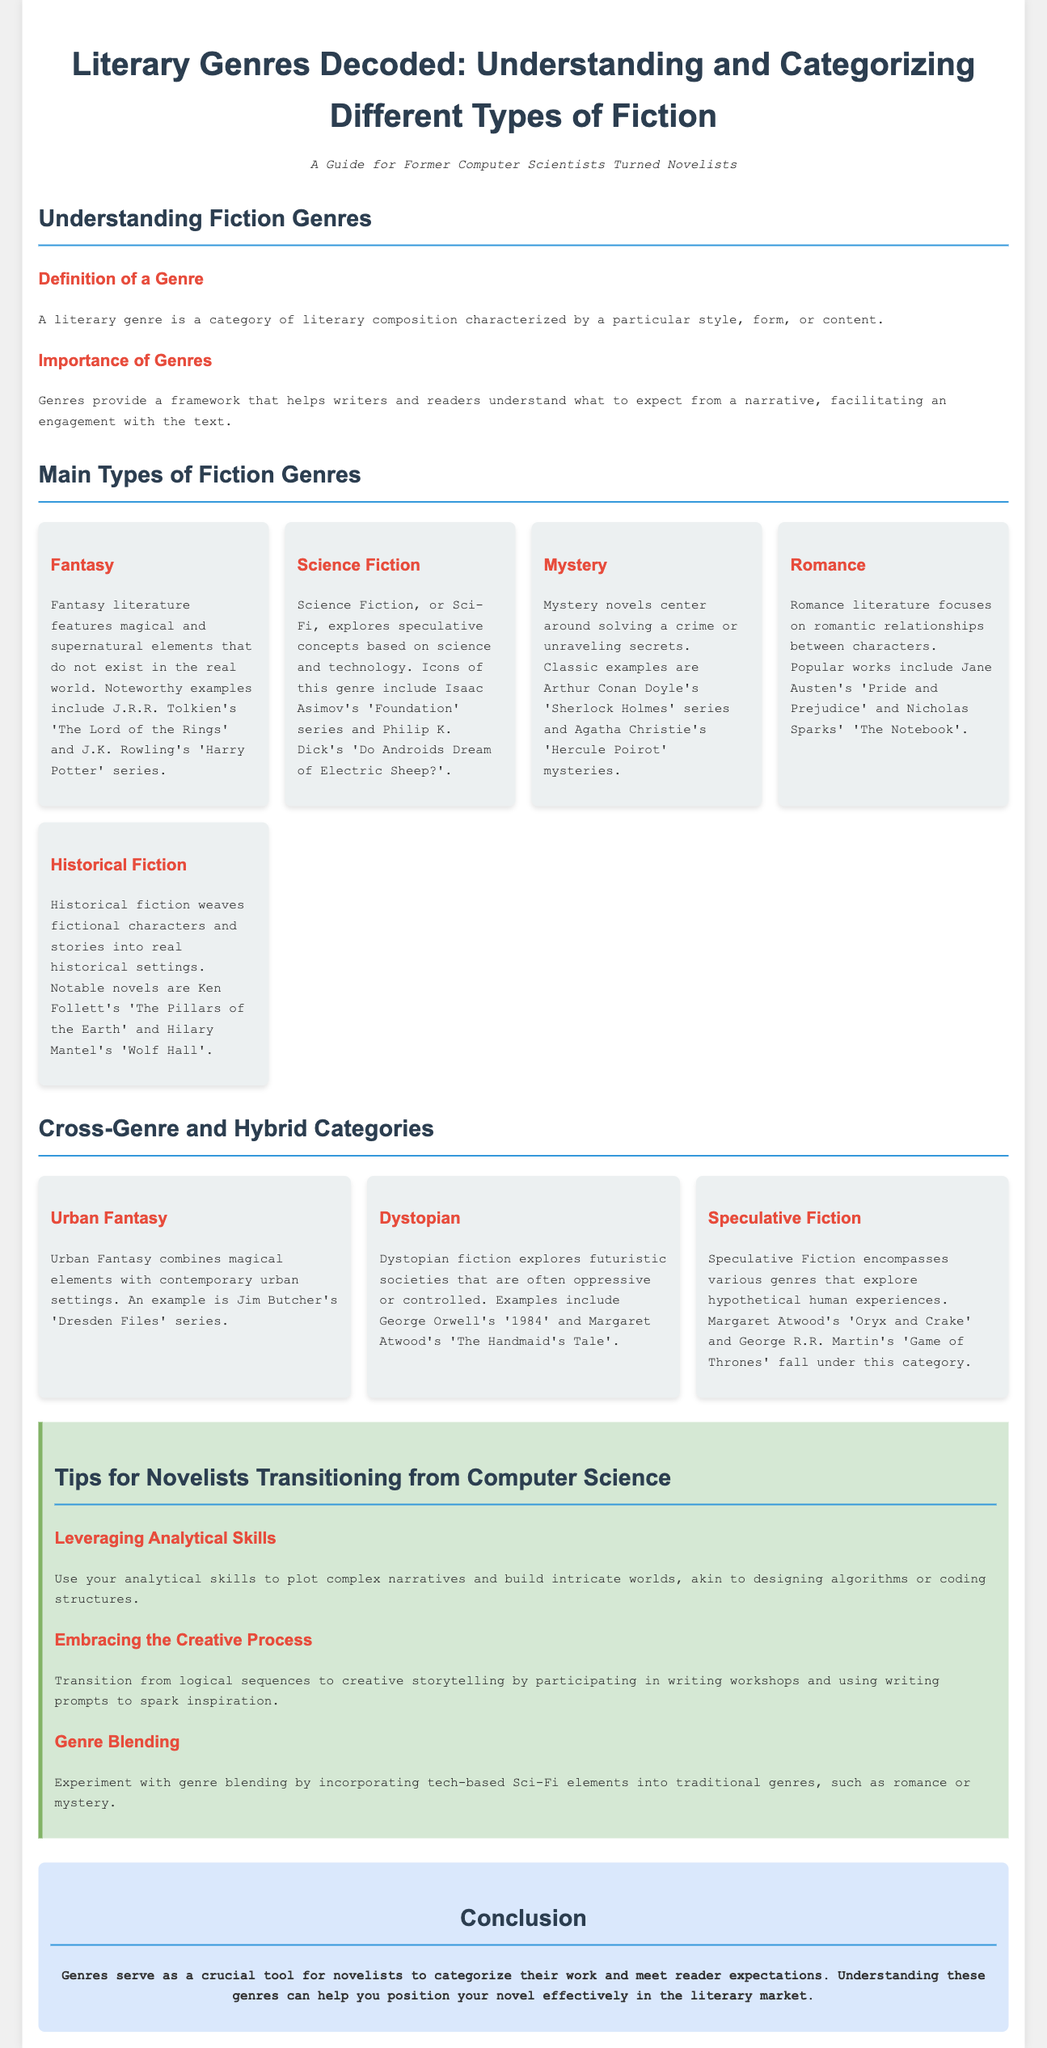what is the title of the document? The title of the document is prominently displayed at the top and summarizes the main topic.
Answer: Literary Genres Decoded: Understanding and Categorizing Different Types of Fiction who is the intended audience for this document? The subtitle indicates that the document is specifically aimed at individuals with a background in technology who are transitioning to writing.
Answer: Former computer scientists turned novelists name two notable examples of Fantasy literature mentioned. The document lists examples of Fantasy literature under the respective genre section, specifically mentioning well-known works.
Answer: J.R.R. Tolkien's 'The Lord of the Rings' and J.K. Rowling's 'Harry Potter' series which genre explores oppressive futuristic societies? The description within the Dystopian genre section highlights that it focuses on themes of oppression.
Answer: Dystopian what is a tip for novelists transitioning from computer science? The tips section offers practical guidance for novelists, emphasizing the importance of their analytical skills in storytelling.
Answer: Use your analytical skills to plot complex narratives how many main types of fiction genres are presented in the document? The document lists a section specifically for main types of fiction genres and counts the number named there.
Answer: Five which genre combines magical elements with contemporary settings? The Urban Fantasy genre is described as incorporating magic in modern-day settings.
Answer: Urban Fantasy what is the main purpose of categorizing literary genres? The document explains that genres provide a framework for engagement with texts, which helps both writers and readers.
Answer: To meet reader expectations 